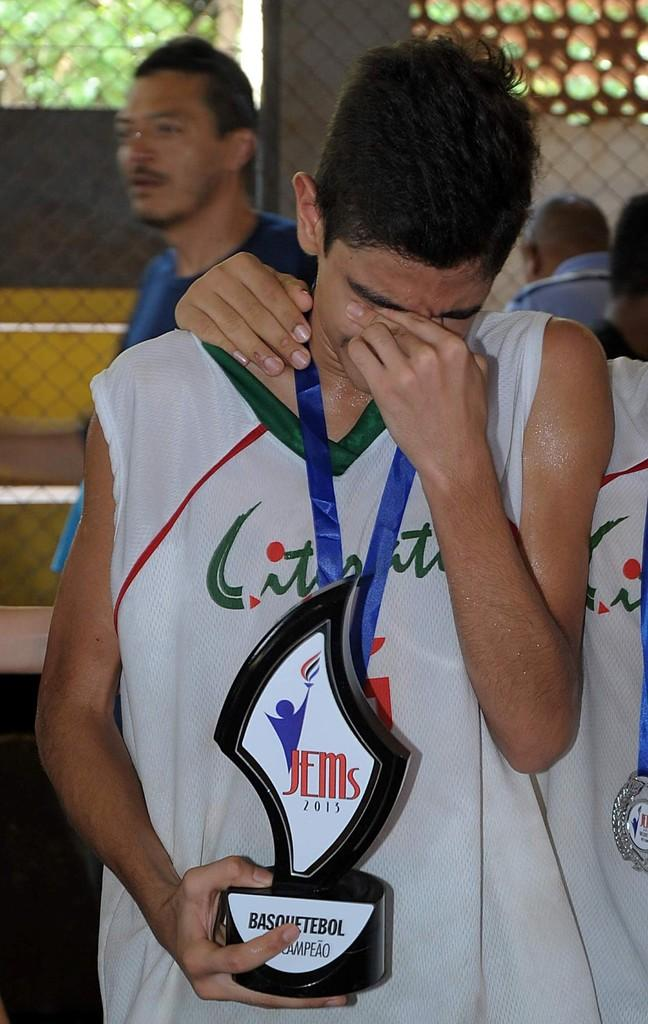Provide a one-sentence caption for the provided image. a boy crying with a JEMs trophy in his hand. 